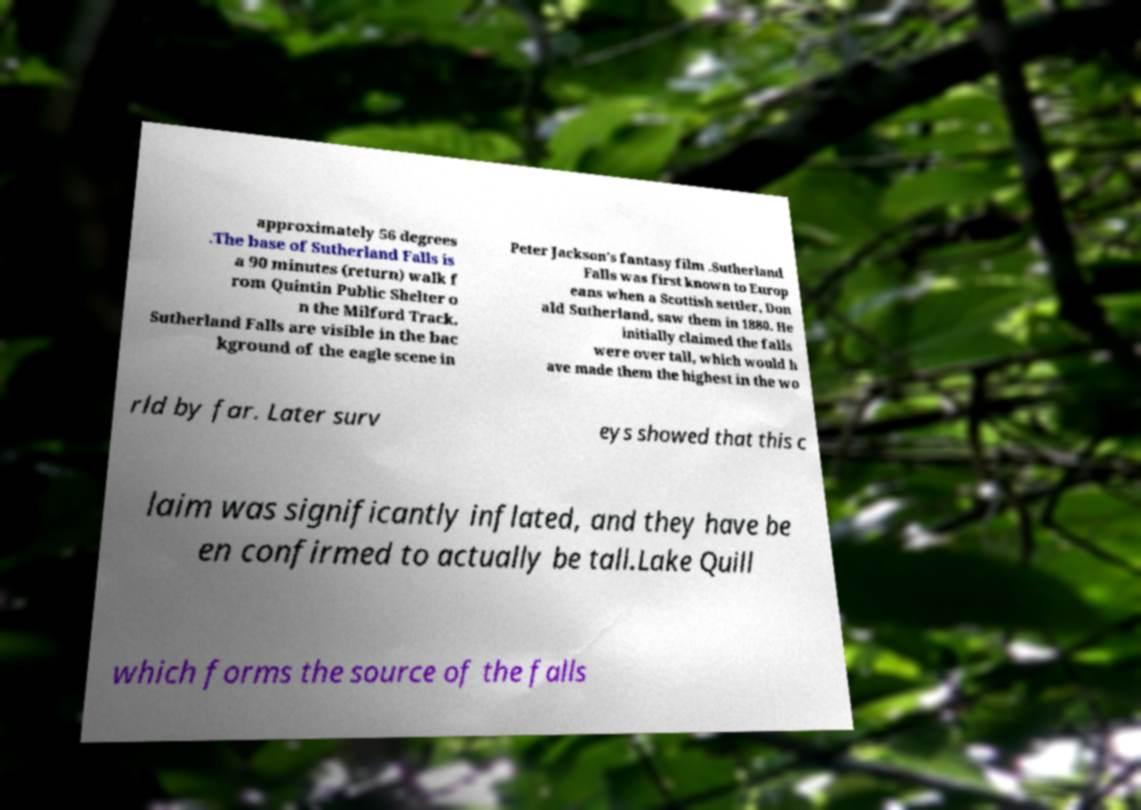For documentation purposes, I need the text within this image transcribed. Could you provide that? approximately 56 degrees .The base of Sutherland Falls is a 90 minutes (return) walk f rom Quintin Public Shelter o n the Milford Track. Sutherland Falls are visible in the bac kground of the eagle scene in Peter Jackson’s fantasy film .Sutherland Falls was first known to Europ eans when a Scottish settler, Don ald Sutherland, saw them in 1880. He initially claimed the falls were over tall, which would h ave made them the highest in the wo rld by far. Later surv eys showed that this c laim was significantly inflated, and they have be en confirmed to actually be tall.Lake Quill which forms the source of the falls 